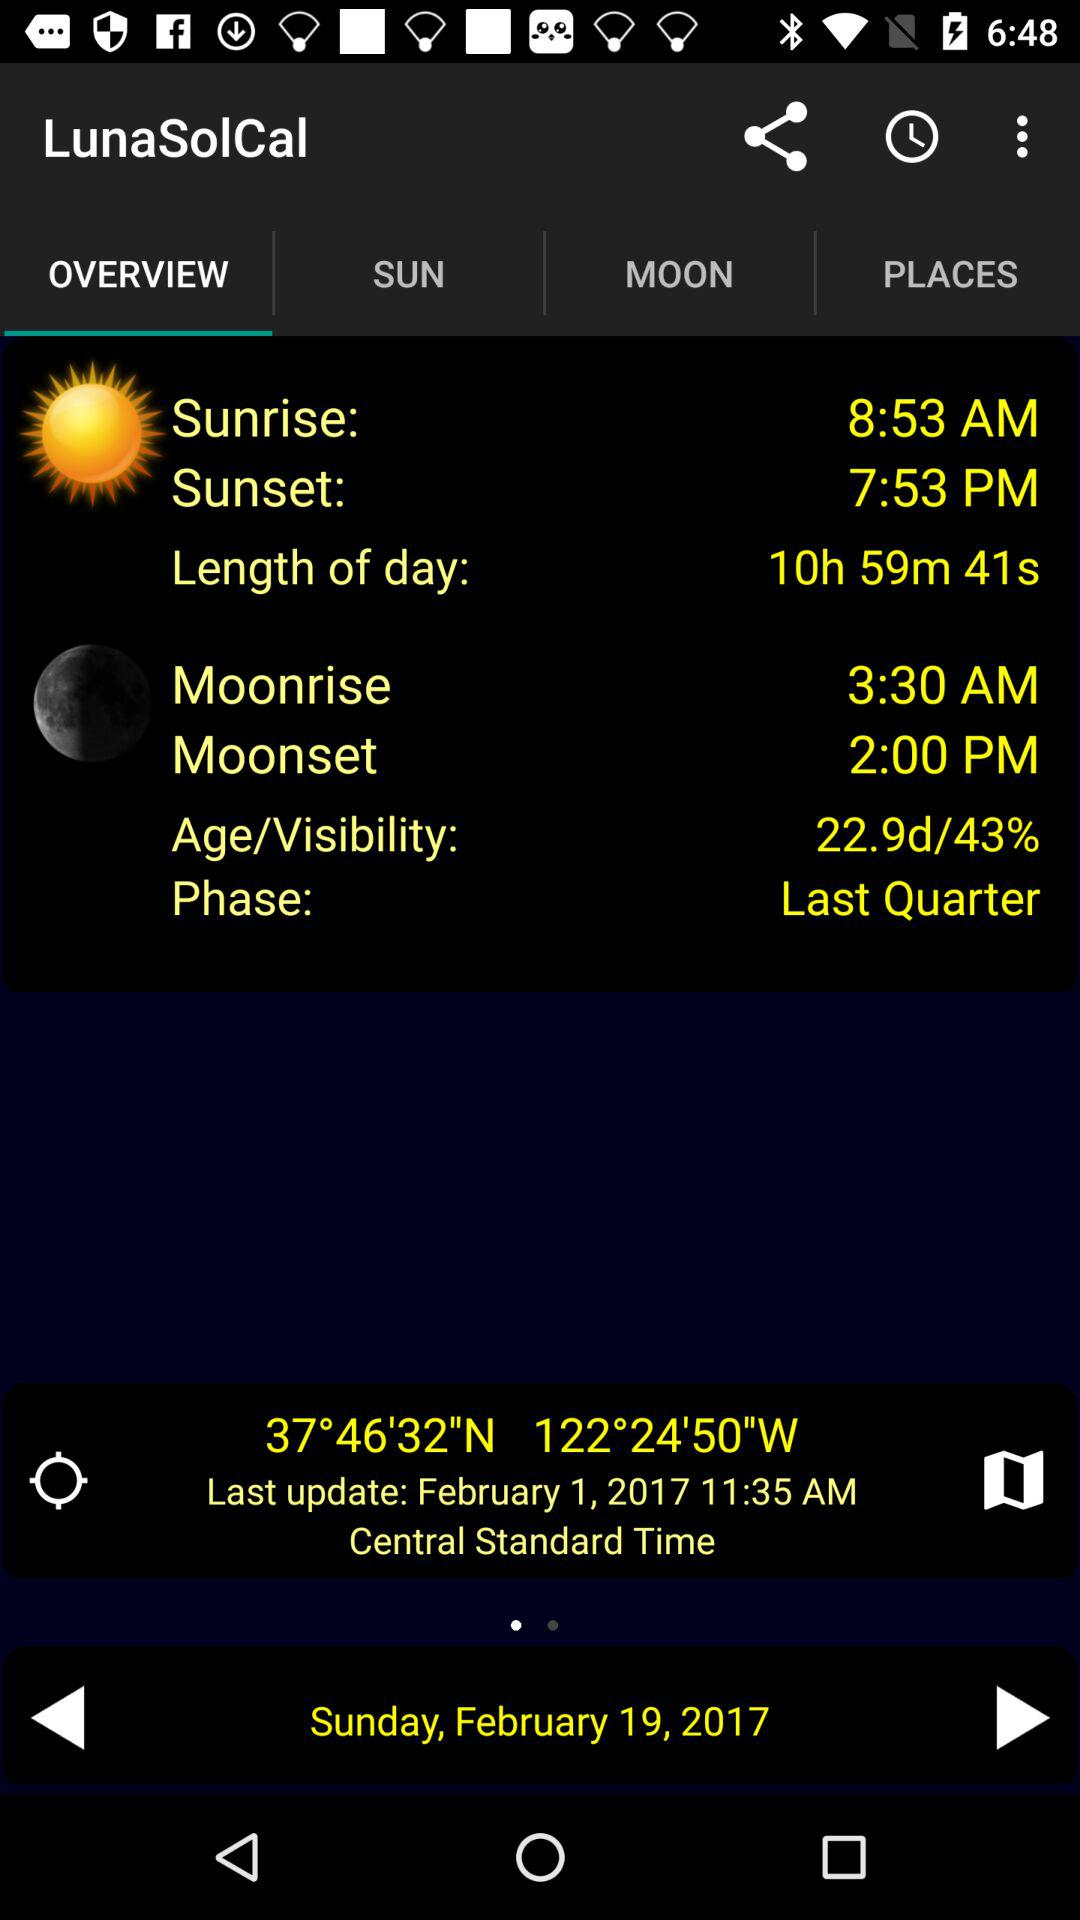When was the last update? The last update was on February 1, 2017. 